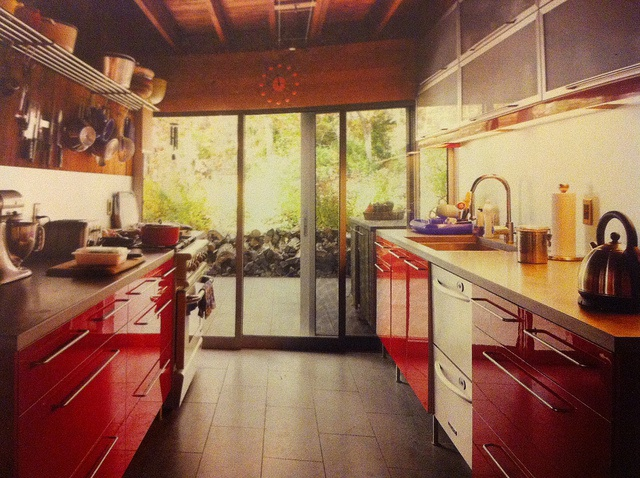Describe the objects in this image and their specific colors. I can see oven in brown, maroon, black, and tan tones, clock in brown and maroon tones, bottle in brown, tan, and orange tones, bowl in brown, maroon, and black tones, and bowl in brown, maroon, and tan tones in this image. 